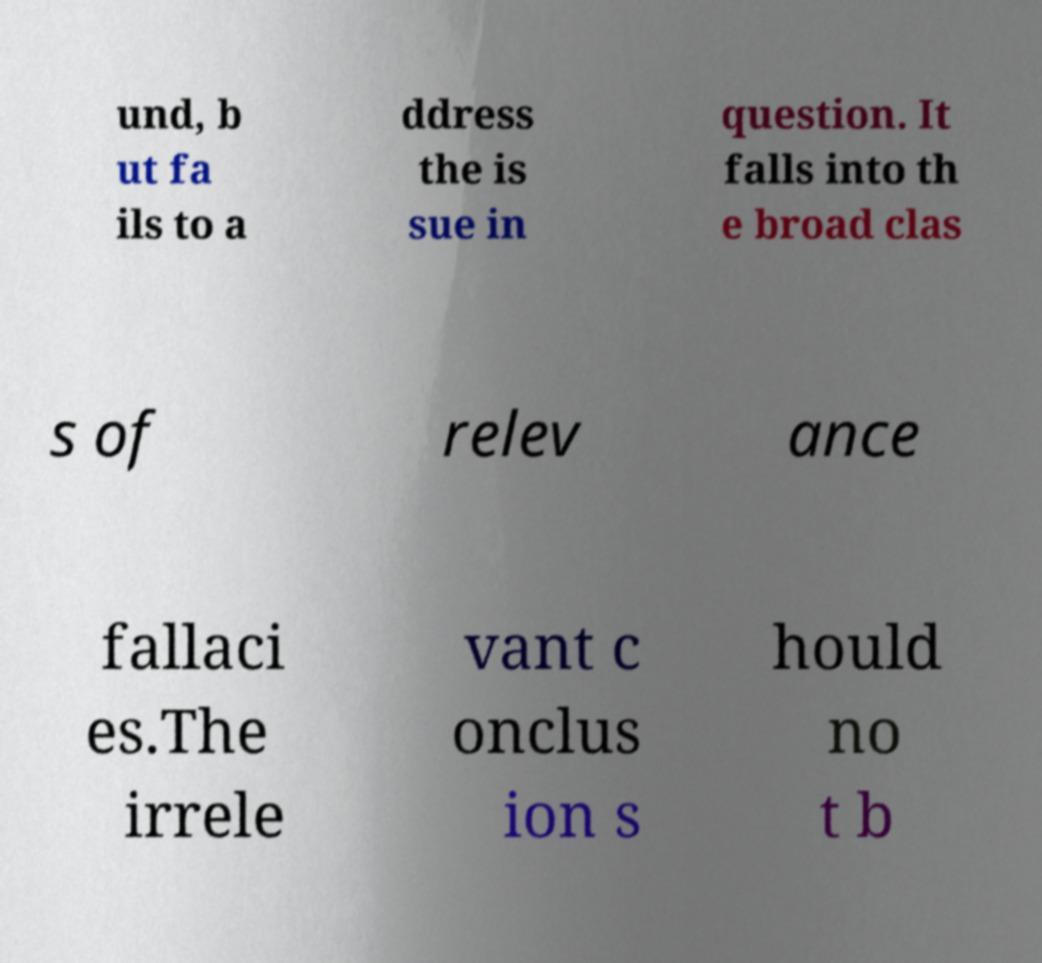For documentation purposes, I need the text within this image transcribed. Could you provide that? und, b ut fa ils to a ddress the is sue in question. It falls into th e broad clas s of relev ance fallaci es.The irrele vant c onclus ion s hould no t b 